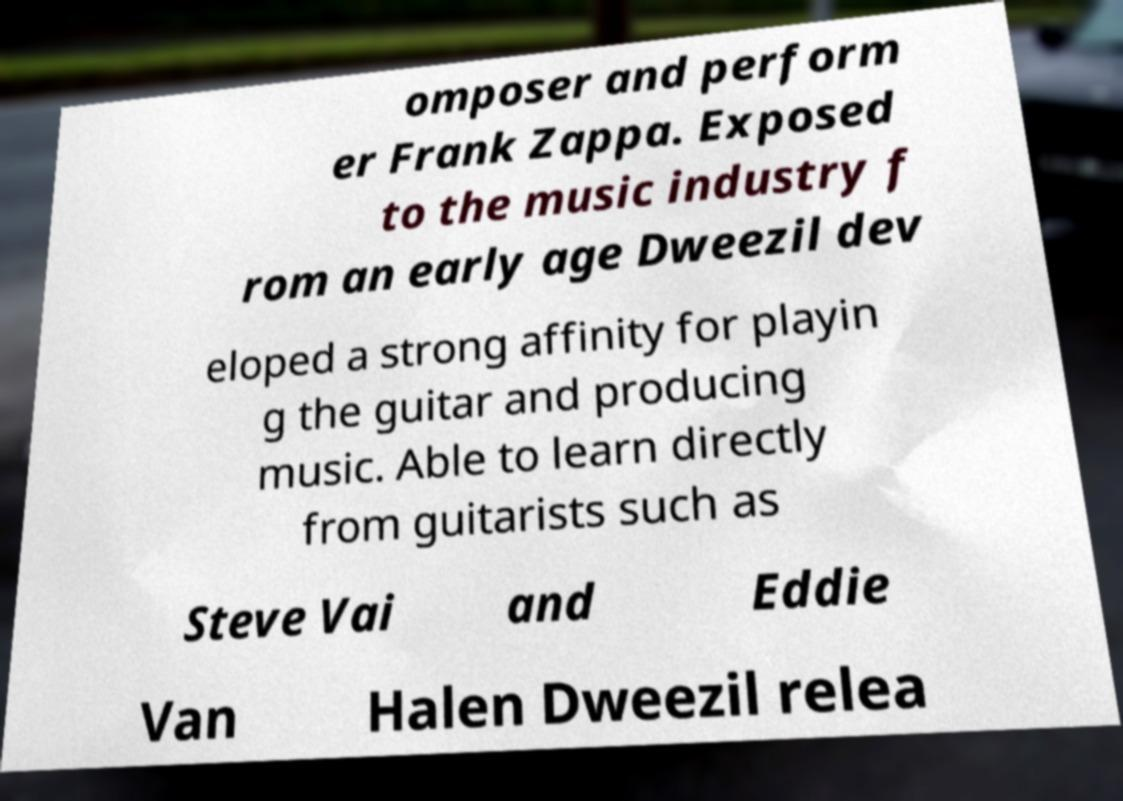Can you accurately transcribe the text from the provided image for me? omposer and perform er Frank Zappa. Exposed to the music industry f rom an early age Dweezil dev eloped a strong affinity for playin g the guitar and producing music. Able to learn directly from guitarists such as Steve Vai and Eddie Van Halen Dweezil relea 